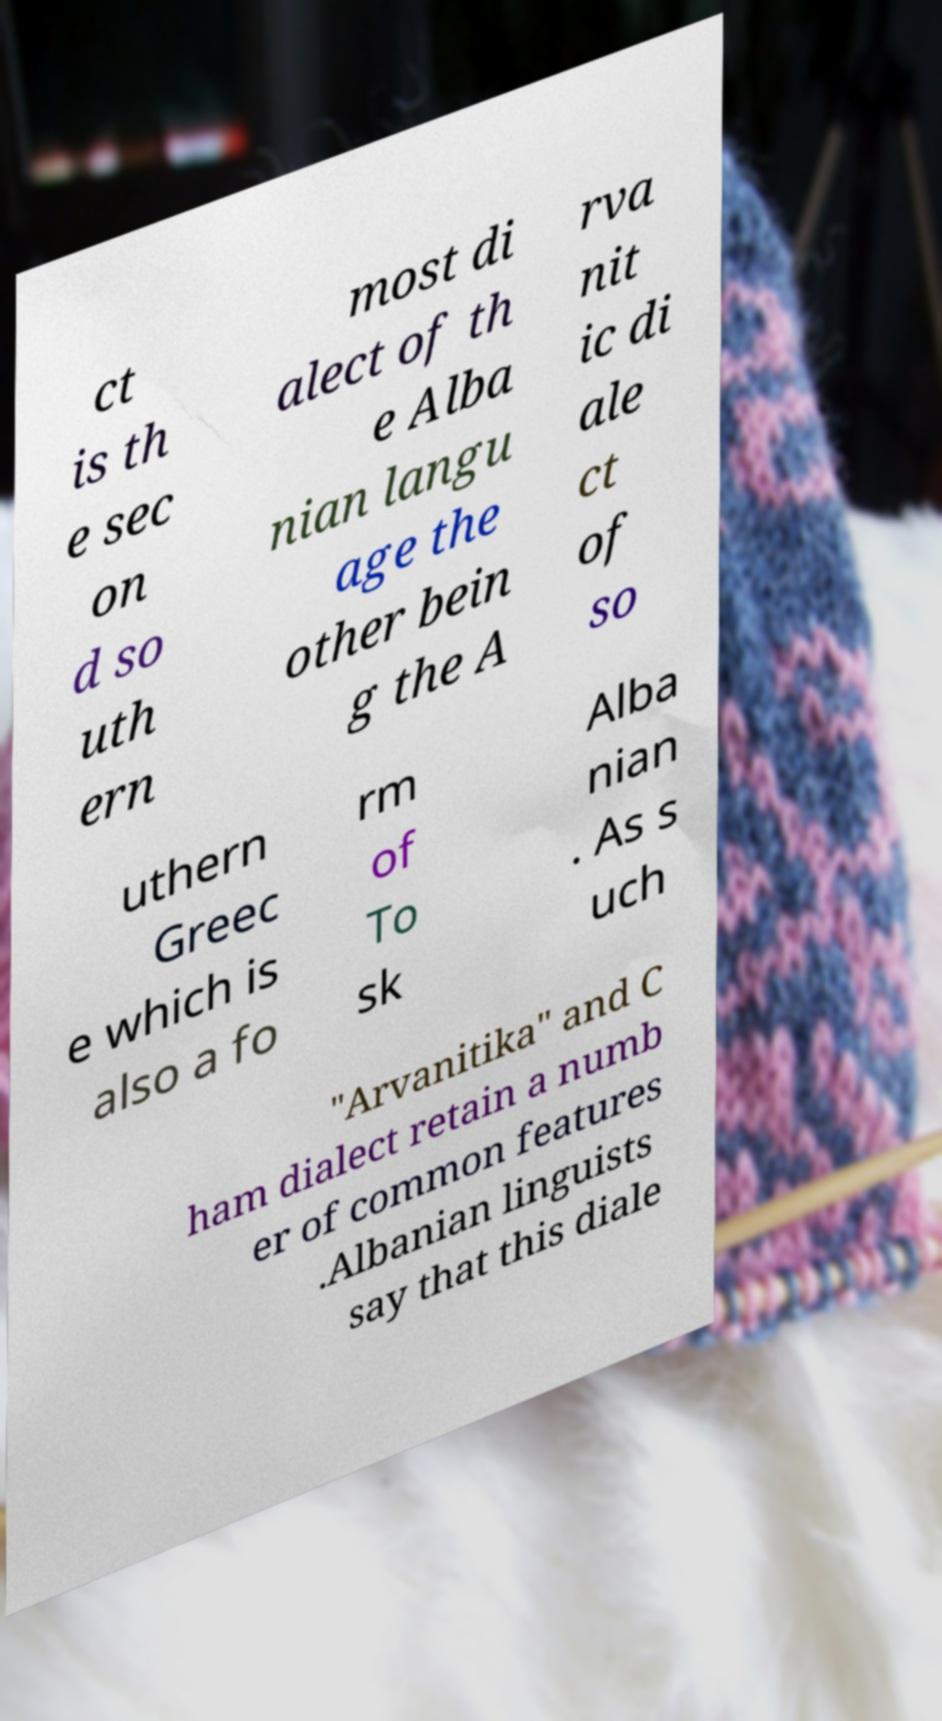For documentation purposes, I need the text within this image transcribed. Could you provide that? ct is th e sec on d so uth ern most di alect of th e Alba nian langu age the other bein g the A rva nit ic di ale ct of so uthern Greec e which is also a fo rm of To sk Alba nian . As s uch "Arvanitika" and C ham dialect retain a numb er of common features .Albanian linguists say that this diale 